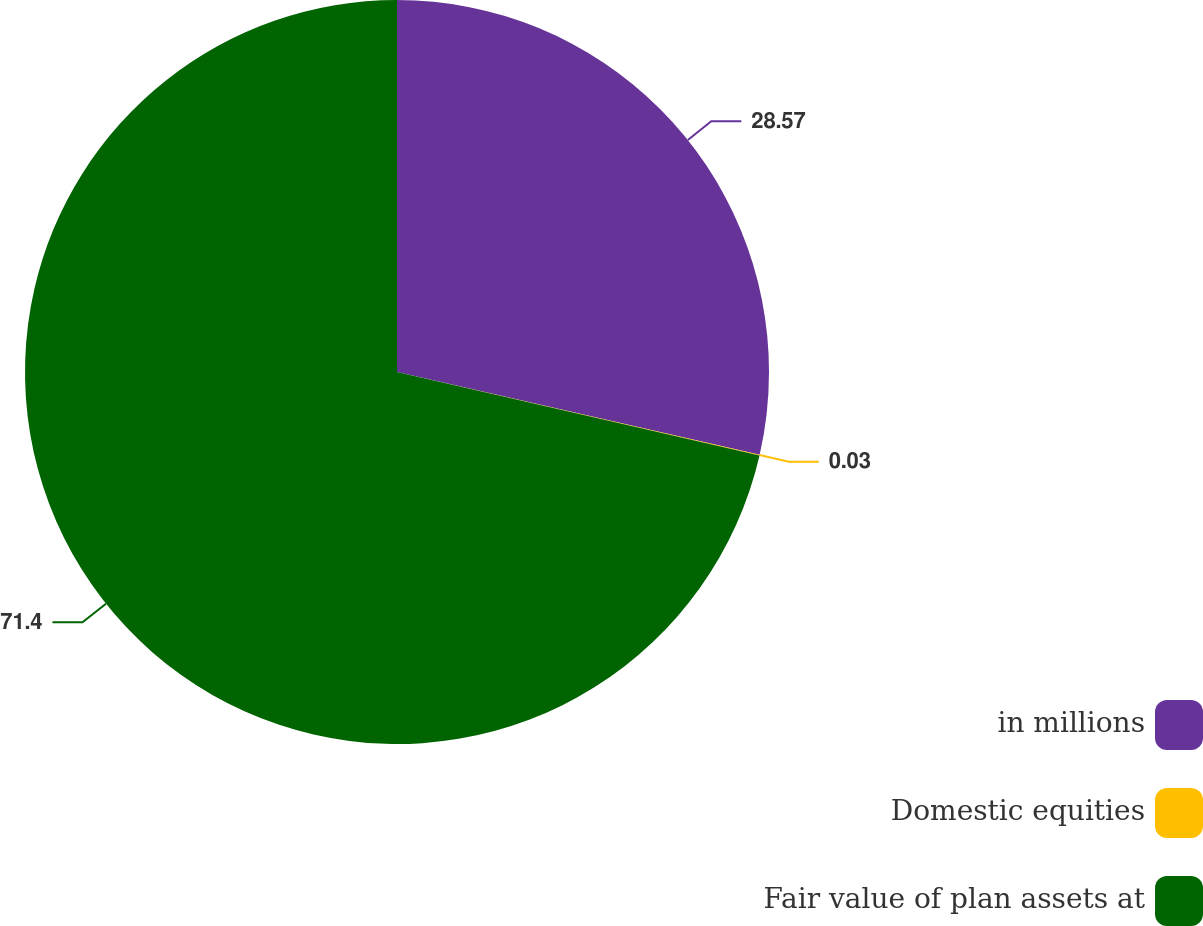<chart> <loc_0><loc_0><loc_500><loc_500><pie_chart><fcel>in millions<fcel>Domestic equities<fcel>Fair value of plan assets at<nl><fcel>28.57%<fcel>0.03%<fcel>71.4%<nl></chart> 